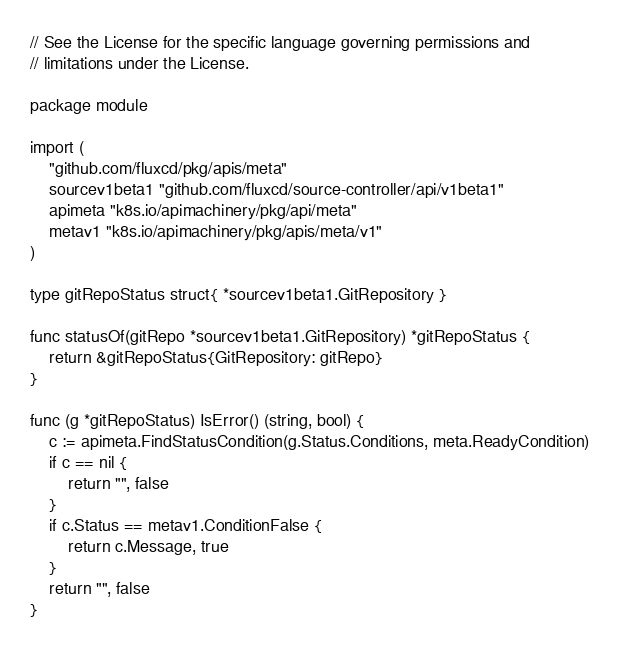<code> <loc_0><loc_0><loc_500><loc_500><_Go_>// See the License for the specific language governing permissions and
// limitations under the License.

package module

import (
	"github.com/fluxcd/pkg/apis/meta"
	sourcev1beta1 "github.com/fluxcd/source-controller/api/v1beta1"
	apimeta "k8s.io/apimachinery/pkg/api/meta"
	metav1 "k8s.io/apimachinery/pkg/apis/meta/v1"
)

type gitRepoStatus struct{ *sourcev1beta1.GitRepository }

func statusOf(gitRepo *sourcev1beta1.GitRepository) *gitRepoStatus {
	return &gitRepoStatus{GitRepository: gitRepo}
}

func (g *gitRepoStatus) IsError() (string, bool) {
	c := apimeta.FindStatusCondition(g.Status.Conditions, meta.ReadyCondition)
	if c == nil {
		return "", false
	}
	if c.Status == metav1.ConditionFalse {
		return c.Message, true
	}
	return "", false
}
</code> 